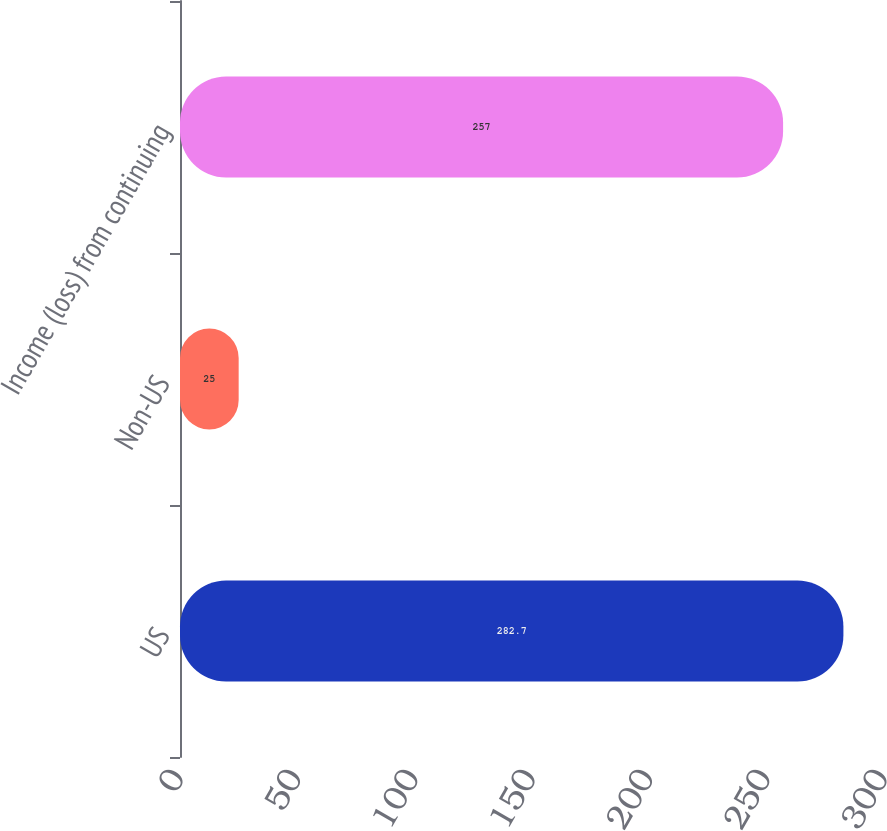Convert chart. <chart><loc_0><loc_0><loc_500><loc_500><bar_chart><fcel>US<fcel>Non-US<fcel>Income (loss) from continuing<nl><fcel>282.7<fcel>25<fcel>257<nl></chart> 